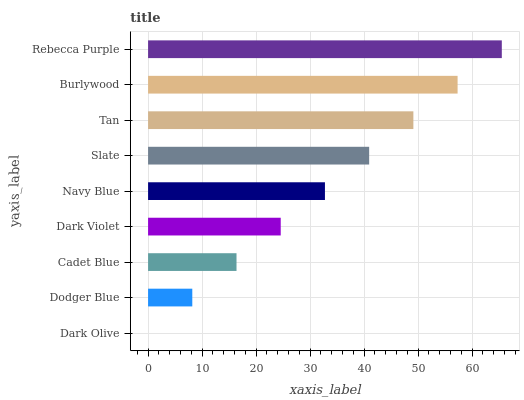Is Dark Olive the minimum?
Answer yes or no. Yes. Is Rebecca Purple the maximum?
Answer yes or no. Yes. Is Dodger Blue the minimum?
Answer yes or no. No. Is Dodger Blue the maximum?
Answer yes or no. No. Is Dodger Blue greater than Dark Olive?
Answer yes or no. Yes. Is Dark Olive less than Dodger Blue?
Answer yes or no. Yes. Is Dark Olive greater than Dodger Blue?
Answer yes or no. No. Is Dodger Blue less than Dark Olive?
Answer yes or no. No. Is Navy Blue the high median?
Answer yes or no. Yes. Is Navy Blue the low median?
Answer yes or no. Yes. Is Burlywood the high median?
Answer yes or no. No. Is Dodger Blue the low median?
Answer yes or no. No. 